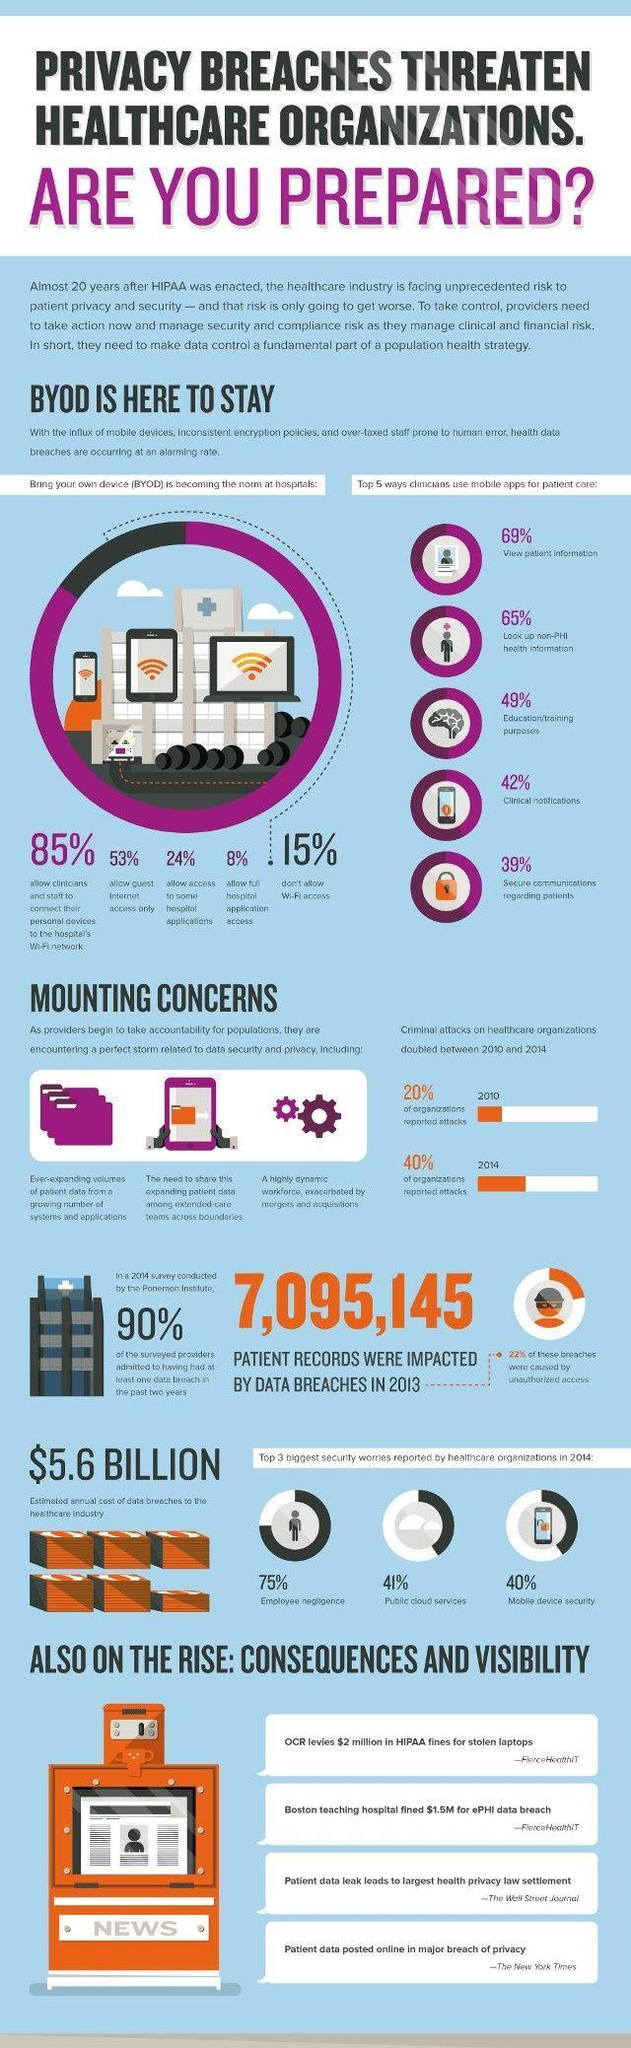What percentage don't allow access to some hospital applications?
Answer the question with a short phrase. 76% What percentage don't allow full hospital application access? 92% What percentage allows wi-fi access? 85% What percentage of organizations reported attacks in the years 2010 and 2014, taken together? 60% What percentage of breaches were not caused by unauthorized access? 78% 